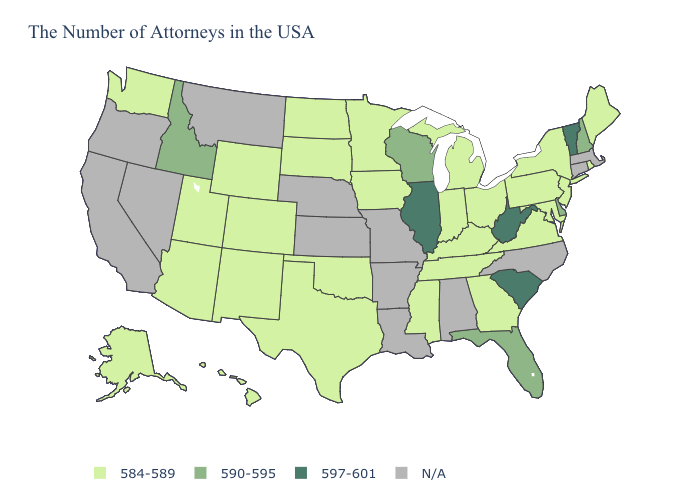Does Vermont have the highest value in the Northeast?
Concise answer only. Yes. Name the states that have a value in the range 590-595?
Concise answer only. New Hampshire, Delaware, Florida, Wisconsin, Idaho. Name the states that have a value in the range 590-595?
Give a very brief answer. New Hampshire, Delaware, Florida, Wisconsin, Idaho. What is the value of Massachusetts?
Write a very short answer. N/A. What is the highest value in the USA?
Keep it brief. 597-601. What is the lowest value in the MidWest?
Concise answer only. 584-589. Name the states that have a value in the range N/A?
Write a very short answer. Massachusetts, Connecticut, North Carolina, Alabama, Louisiana, Missouri, Arkansas, Kansas, Nebraska, Montana, Nevada, California, Oregon. Name the states that have a value in the range 590-595?
Keep it brief. New Hampshire, Delaware, Florida, Wisconsin, Idaho. Which states have the lowest value in the USA?
Give a very brief answer. Maine, Rhode Island, New York, New Jersey, Maryland, Pennsylvania, Virginia, Ohio, Georgia, Michigan, Kentucky, Indiana, Tennessee, Mississippi, Minnesota, Iowa, Oklahoma, Texas, South Dakota, North Dakota, Wyoming, Colorado, New Mexico, Utah, Arizona, Washington, Alaska, Hawaii. What is the lowest value in the MidWest?
Keep it brief. 584-589. What is the highest value in the Northeast ?
Concise answer only. 597-601. Does the first symbol in the legend represent the smallest category?
Quick response, please. Yes. 